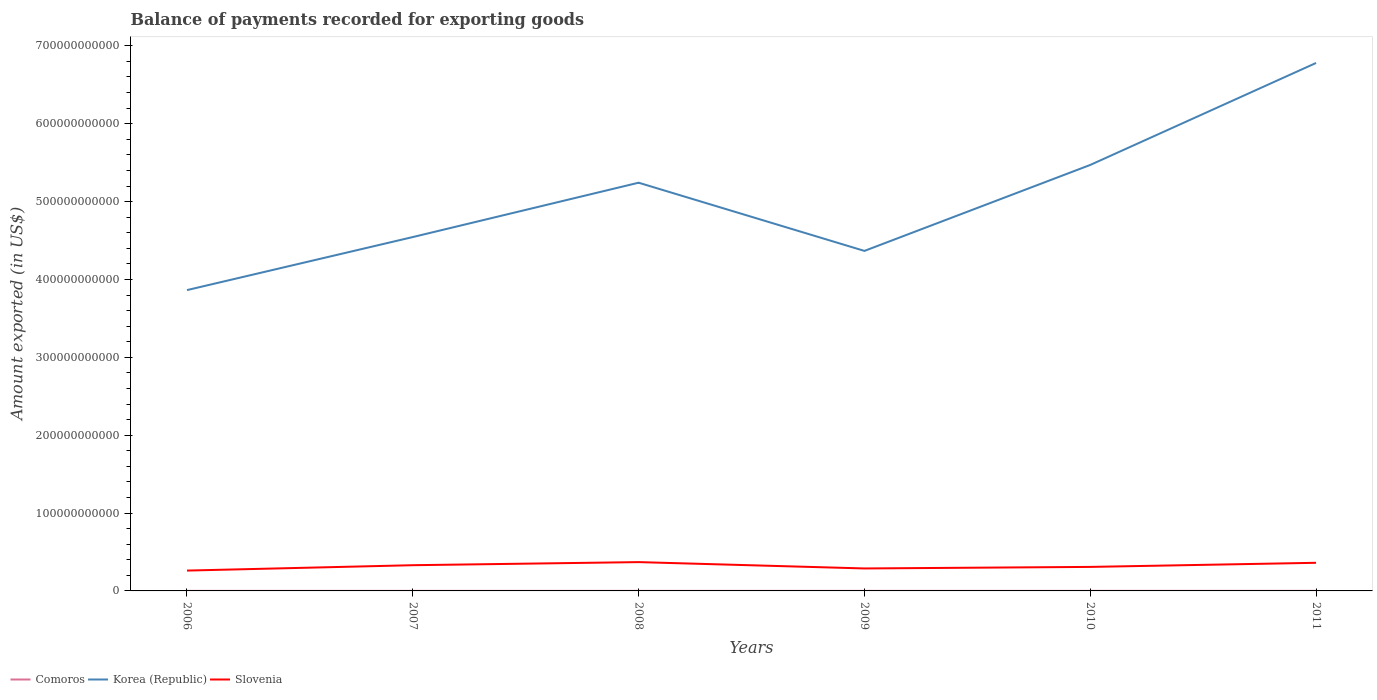Across all years, what is the maximum amount exported in Comoros?
Your response must be concise. 6.01e+07. What is the total amount exported in Korea (Republic) in the graph?
Your answer should be compact. 8.76e+1. What is the difference between the highest and the second highest amount exported in Comoros?
Ensure brevity in your answer.  3.95e+07. What is the difference between the highest and the lowest amount exported in Korea (Republic)?
Provide a succinct answer. 3. How many years are there in the graph?
Offer a terse response. 6. What is the difference between two consecutive major ticks on the Y-axis?
Your answer should be compact. 1.00e+11. Are the values on the major ticks of Y-axis written in scientific E-notation?
Offer a very short reply. No. Does the graph contain grids?
Offer a terse response. No. Where does the legend appear in the graph?
Keep it short and to the point. Bottom left. What is the title of the graph?
Your answer should be very brief. Balance of payments recorded for exporting goods. Does "Latin America(all income levels)" appear as one of the legend labels in the graph?
Your answer should be very brief. No. What is the label or title of the X-axis?
Your answer should be compact. Years. What is the label or title of the Y-axis?
Keep it short and to the point. Amount exported (in US$). What is the Amount exported (in US$) in Comoros in 2006?
Keep it short and to the point. 6.01e+07. What is the Amount exported (in US$) of Korea (Republic) in 2006?
Ensure brevity in your answer.  3.86e+11. What is the Amount exported (in US$) of Slovenia in 2006?
Provide a short and direct response. 2.61e+1. What is the Amount exported (in US$) of Comoros in 2007?
Your answer should be compact. 7.15e+07. What is the Amount exported (in US$) of Korea (Republic) in 2007?
Provide a succinct answer. 4.54e+11. What is the Amount exported (in US$) of Slovenia in 2007?
Your answer should be compact. 3.30e+1. What is the Amount exported (in US$) in Comoros in 2008?
Your response must be concise. 7.41e+07. What is the Amount exported (in US$) in Korea (Republic) in 2008?
Ensure brevity in your answer.  5.24e+11. What is the Amount exported (in US$) of Slovenia in 2008?
Provide a succinct answer. 3.70e+1. What is the Amount exported (in US$) in Comoros in 2009?
Ensure brevity in your answer.  7.77e+07. What is the Amount exported (in US$) of Korea (Republic) in 2009?
Provide a succinct answer. 4.37e+11. What is the Amount exported (in US$) in Slovenia in 2009?
Your response must be concise. 2.88e+1. What is the Amount exported (in US$) of Comoros in 2010?
Make the answer very short. 8.74e+07. What is the Amount exported (in US$) of Korea (Republic) in 2010?
Keep it short and to the point. 5.47e+11. What is the Amount exported (in US$) of Slovenia in 2010?
Give a very brief answer. 3.08e+1. What is the Amount exported (in US$) in Comoros in 2011?
Your answer should be very brief. 9.96e+07. What is the Amount exported (in US$) of Korea (Republic) in 2011?
Give a very brief answer. 6.78e+11. What is the Amount exported (in US$) of Slovenia in 2011?
Provide a short and direct response. 3.61e+1. Across all years, what is the maximum Amount exported (in US$) of Comoros?
Give a very brief answer. 9.96e+07. Across all years, what is the maximum Amount exported (in US$) of Korea (Republic)?
Offer a terse response. 6.78e+11. Across all years, what is the maximum Amount exported (in US$) of Slovenia?
Your response must be concise. 3.70e+1. Across all years, what is the minimum Amount exported (in US$) of Comoros?
Your answer should be very brief. 6.01e+07. Across all years, what is the minimum Amount exported (in US$) in Korea (Republic)?
Make the answer very short. 3.86e+11. Across all years, what is the minimum Amount exported (in US$) in Slovenia?
Give a very brief answer. 2.61e+1. What is the total Amount exported (in US$) in Comoros in the graph?
Offer a terse response. 4.71e+08. What is the total Amount exported (in US$) of Korea (Republic) in the graph?
Offer a terse response. 3.03e+12. What is the total Amount exported (in US$) in Slovenia in the graph?
Make the answer very short. 1.92e+11. What is the difference between the Amount exported (in US$) in Comoros in 2006 and that in 2007?
Your answer should be compact. -1.14e+07. What is the difference between the Amount exported (in US$) of Korea (Republic) in 2006 and that in 2007?
Make the answer very short. -6.81e+1. What is the difference between the Amount exported (in US$) in Slovenia in 2006 and that in 2007?
Make the answer very short. -6.91e+09. What is the difference between the Amount exported (in US$) of Comoros in 2006 and that in 2008?
Give a very brief answer. -1.40e+07. What is the difference between the Amount exported (in US$) in Korea (Republic) in 2006 and that in 2008?
Ensure brevity in your answer.  -1.38e+11. What is the difference between the Amount exported (in US$) in Slovenia in 2006 and that in 2008?
Your answer should be very brief. -1.09e+1. What is the difference between the Amount exported (in US$) in Comoros in 2006 and that in 2009?
Ensure brevity in your answer.  -1.76e+07. What is the difference between the Amount exported (in US$) of Korea (Republic) in 2006 and that in 2009?
Ensure brevity in your answer.  -5.03e+1. What is the difference between the Amount exported (in US$) in Slovenia in 2006 and that in 2009?
Your answer should be very brief. -2.73e+09. What is the difference between the Amount exported (in US$) of Comoros in 2006 and that in 2010?
Your response must be concise. -2.73e+07. What is the difference between the Amount exported (in US$) in Korea (Republic) in 2006 and that in 2010?
Ensure brevity in your answer.  -1.61e+11. What is the difference between the Amount exported (in US$) of Slovenia in 2006 and that in 2010?
Offer a very short reply. -4.72e+09. What is the difference between the Amount exported (in US$) of Comoros in 2006 and that in 2011?
Ensure brevity in your answer.  -3.95e+07. What is the difference between the Amount exported (in US$) of Korea (Republic) in 2006 and that in 2011?
Make the answer very short. -2.92e+11. What is the difference between the Amount exported (in US$) of Slovenia in 2006 and that in 2011?
Keep it short and to the point. -9.99e+09. What is the difference between the Amount exported (in US$) of Comoros in 2007 and that in 2008?
Your response must be concise. -2.64e+06. What is the difference between the Amount exported (in US$) of Korea (Republic) in 2007 and that in 2008?
Your response must be concise. -6.98e+1. What is the difference between the Amount exported (in US$) in Slovenia in 2007 and that in 2008?
Give a very brief answer. -3.97e+09. What is the difference between the Amount exported (in US$) in Comoros in 2007 and that in 2009?
Give a very brief answer. -6.22e+06. What is the difference between the Amount exported (in US$) of Korea (Republic) in 2007 and that in 2009?
Give a very brief answer. 1.78e+1. What is the difference between the Amount exported (in US$) in Slovenia in 2007 and that in 2009?
Provide a succinct answer. 4.18e+09. What is the difference between the Amount exported (in US$) of Comoros in 2007 and that in 2010?
Your answer should be compact. -1.59e+07. What is the difference between the Amount exported (in US$) in Korea (Republic) in 2007 and that in 2010?
Make the answer very short. -9.26e+1. What is the difference between the Amount exported (in US$) of Slovenia in 2007 and that in 2010?
Make the answer very short. 2.19e+09. What is the difference between the Amount exported (in US$) in Comoros in 2007 and that in 2011?
Offer a very short reply. -2.82e+07. What is the difference between the Amount exported (in US$) in Korea (Republic) in 2007 and that in 2011?
Your answer should be very brief. -2.24e+11. What is the difference between the Amount exported (in US$) of Slovenia in 2007 and that in 2011?
Offer a very short reply. -3.08e+09. What is the difference between the Amount exported (in US$) of Comoros in 2008 and that in 2009?
Offer a very short reply. -3.57e+06. What is the difference between the Amount exported (in US$) in Korea (Republic) in 2008 and that in 2009?
Offer a very short reply. 8.76e+1. What is the difference between the Amount exported (in US$) in Slovenia in 2008 and that in 2009?
Provide a short and direct response. 8.15e+09. What is the difference between the Amount exported (in US$) in Comoros in 2008 and that in 2010?
Keep it short and to the point. -1.33e+07. What is the difference between the Amount exported (in US$) of Korea (Republic) in 2008 and that in 2010?
Your answer should be very brief. -2.28e+1. What is the difference between the Amount exported (in US$) in Slovenia in 2008 and that in 2010?
Provide a short and direct response. 6.16e+09. What is the difference between the Amount exported (in US$) of Comoros in 2008 and that in 2011?
Keep it short and to the point. -2.55e+07. What is the difference between the Amount exported (in US$) of Korea (Republic) in 2008 and that in 2011?
Give a very brief answer. -1.54e+11. What is the difference between the Amount exported (in US$) of Slovenia in 2008 and that in 2011?
Make the answer very short. 8.89e+08. What is the difference between the Amount exported (in US$) of Comoros in 2009 and that in 2010?
Provide a succinct answer. -9.73e+06. What is the difference between the Amount exported (in US$) in Korea (Republic) in 2009 and that in 2010?
Ensure brevity in your answer.  -1.10e+11. What is the difference between the Amount exported (in US$) in Slovenia in 2009 and that in 2010?
Keep it short and to the point. -1.99e+09. What is the difference between the Amount exported (in US$) in Comoros in 2009 and that in 2011?
Your answer should be compact. -2.19e+07. What is the difference between the Amount exported (in US$) of Korea (Republic) in 2009 and that in 2011?
Your response must be concise. -2.41e+11. What is the difference between the Amount exported (in US$) in Slovenia in 2009 and that in 2011?
Provide a short and direct response. -7.26e+09. What is the difference between the Amount exported (in US$) in Comoros in 2010 and that in 2011?
Offer a terse response. -1.22e+07. What is the difference between the Amount exported (in US$) in Korea (Republic) in 2010 and that in 2011?
Provide a short and direct response. -1.31e+11. What is the difference between the Amount exported (in US$) in Slovenia in 2010 and that in 2011?
Give a very brief answer. -5.27e+09. What is the difference between the Amount exported (in US$) of Comoros in 2006 and the Amount exported (in US$) of Korea (Republic) in 2007?
Offer a very short reply. -4.54e+11. What is the difference between the Amount exported (in US$) in Comoros in 2006 and the Amount exported (in US$) in Slovenia in 2007?
Provide a short and direct response. -3.30e+1. What is the difference between the Amount exported (in US$) in Korea (Republic) in 2006 and the Amount exported (in US$) in Slovenia in 2007?
Your response must be concise. 3.53e+11. What is the difference between the Amount exported (in US$) in Comoros in 2006 and the Amount exported (in US$) in Korea (Republic) in 2008?
Your response must be concise. -5.24e+11. What is the difference between the Amount exported (in US$) of Comoros in 2006 and the Amount exported (in US$) of Slovenia in 2008?
Provide a succinct answer. -3.69e+1. What is the difference between the Amount exported (in US$) of Korea (Republic) in 2006 and the Amount exported (in US$) of Slovenia in 2008?
Offer a terse response. 3.49e+11. What is the difference between the Amount exported (in US$) of Comoros in 2006 and the Amount exported (in US$) of Korea (Republic) in 2009?
Your answer should be very brief. -4.37e+11. What is the difference between the Amount exported (in US$) of Comoros in 2006 and the Amount exported (in US$) of Slovenia in 2009?
Make the answer very short. -2.88e+1. What is the difference between the Amount exported (in US$) of Korea (Republic) in 2006 and the Amount exported (in US$) of Slovenia in 2009?
Make the answer very short. 3.57e+11. What is the difference between the Amount exported (in US$) in Comoros in 2006 and the Amount exported (in US$) in Korea (Republic) in 2010?
Your answer should be very brief. -5.47e+11. What is the difference between the Amount exported (in US$) of Comoros in 2006 and the Amount exported (in US$) of Slovenia in 2010?
Offer a terse response. -3.08e+1. What is the difference between the Amount exported (in US$) of Korea (Republic) in 2006 and the Amount exported (in US$) of Slovenia in 2010?
Offer a very short reply. 3.55e+11. What is the difference between the Amount exported (in US$) in Comoros in 2006 and the Amount exported (in US$) in Korea (Republic) in 2011?
Keep it short and to the point. -6.78e+11. What is the difference between the Amount exported (in US$) in Comoros in 2006 and the Amount exported (in US$) in Slovenia in 2011?
Provide a short and direct response. -3.61e+1. What is the difference between the Amount exported (in US$) in Korea (Republic) in 2006 and the Amount exported (in US$) in Slovenia in 2011?
Give a very brief answer. 3.50e+11. What is the difference between the Amount exported (in US$) in Comoros in 2007 and the Amount exported (in US$) in Korea (Republic) in 2008?
Provide a short and direct response. -5.24e+11. What is the difference between the Amount exported (in US$) in Comoros in 2007 and the Amount exported (in US$) in Slovenia in 2008?
Keep it short and to the point. -3.69e+1. What is the difference between the Amount exported (in US$) in Korea (Republic) in 2007 and the Amount exported (in US$) in Slovenia in 2008?
Keep it short and to the point. 4.17e+11. What is the difference between the Amount exported (in US$) in Comoros in 2007 and the Amount exported (in US$) in Korea (Republic) in 2009?
Your answer should be compact. -4.37e+11. What is the difference between the Amount exported (in US$) of Comoros in 2007 and the Amount exported (in US$) of Slovenia in 2009?
Keep it short and to the point. -2.88e+1. What is the difference between the Amount exported (in US$) of Korea (Republic) in 2007 and the Amount exported (in US$) of Slovenia in 2009?
Ensure brevity in your answer.  4.26e+11. What is the difference between the Amount exported (in US$) in Comoros in 2007 and the Amount exported (in US$) in Korea (Republic) in 2010?
Make the answer very short. -5.47e+11. What is the difference between the Amount exported (in US$) in Comoros in 2007 and the Amount exported (in US$) in Slovenia in 2010?
Ensure brevity in your answer.  -3.08e+1. What is the difference between the Amount exported (in US$) of Korea (Republic) in 2007 and the Amount exported (in US$) of Slovenia in 2010?
Your response must be concise. 4.24e+11. What is the difference between the Amount exported (in US$) of Comoros in 2007 and the Amount exported (in US$) of Korea (Republic) in 2011?
Offer a very short reply. -6.78e+11. What is the difference between the Amount exported (in US$) in Comoros in 2007 and the Amount exported (in US$) in Slovenia in 2011?
Make the answer very short. -3.60e+1. What is the difference between the Amount exported (in US$) in Korea (Republic) in 2007 and the Amount exported (in US$) in Slovenia in 2011?
Your answer should be very brief. 4.18e+11. What is the difference between the Amount exported (in US$) in Comoros in 2008 and the Amount exported (in US$) in Korea (Republic) in 2009?
Provide a short and direct response. -4.37e+11. What is the difference between the Amount exported (in US$) of Comoros in 2008 and the Amount exported (in US$) of Slovenia in 2009?
Offer a terse response. -2.88e+1. What is the difference between the Amount exported (in US$) in Korea (Republic) in 2008 and the Amount exported (in US$) in Slovenia in 2009?
Ensure brevity in your answer.  4.95e+11. What is the difference between the Amount exported (in US$) in Comoros in 2008 and the Amount exported (in US$) in Korea (Republic) in 2010?
Make the answer very short. -5.47e+11. What is the difference between the Amount exported (in US$) in Comoros in 2008 and the Amount exported (in US$) in Slovenia in 2010?
Ensure brevity in your answer.  -3.08e+1. What is the difference between the Amount exported (in US$) in Korea (Republic) in 2008 and the Amount exported (in US$) in Slovenia in 2010?
Offer a terse response. 4.93e+11. What is the difference between the Amount exported (in US$) in Comoros in 2008 and the Amount exported (in US$) in Korea (Republic) in 2011?
Offer a very short reply. -6.78e+11. What is the difference between the Amount exported (in US$) in Comoros in 2008 and the Amount exported (in US$) in Slovenia in 2011?
Offer a terse response. -3.60e+1. What is the difference between the Amount exported (in US$) in Korea (Republic) in 2008 and the Amount exported (in US$) in Slovenia in 2011?
Give a very brief answer. 4.88e+11. What is the difference between the Amount exported (in US$) in Comoros in 2009 and the Amount exported (in US$) in Korea (Republic) in 2010?
Provide a short and direct response. -5.47e+11. What is the difference between the Amount exported (in US$) in Comoros in 2009 and the Amount exported (in US$) in Slovenia in 2010?
Keep it short and to the point. -3.08e+1. What is the difference between the Amount exported (in US$) of Korea (Republic) in 2009 and the Amount exported (in US$) of Slovenia in 2010?
Your answer should be very brief. 4.06e+11. What is the difference between the Amount exported (in US$) of Comoros in 2009 and the Amount exported (in US$) of Korea (Republic) in 2011?
Your answer should be very brief. -6.78e+11. What is the difference between the Amount exported (in US$) in Comoros in 2009 and the Amount exported (in US$) in Slovenia in 2011?
Make the answer very short. -3.60e+1. What is the difference between the Amount exported (in US$) in Korea (Republic) in 2009 and the Amount exported (in US$) in Slovenia in 2011?
Offer a very short reply. 4.01e+11. What is the difference between the Amount exported (in US$) in Comoros in 2010 and the Amount exported (in US$) in Korea (Republic) in 2011?
Make the answer very short. -6.78e+11. What is the difference between the Amount exported (in US$) of Comoros in 2010 and the Amount exported (in US$) of Slovenia in 2011?
Ensure brevity in your answer.  -3.60e+1. What is the difference between the Amount exported (in US$) in Korea (Republic) in 2010 and the Amount exported (in US$) in Slovenia in 2011?
Offer a very short reply. 5.11e+11. What is the average Amount exported (in US$) of Comoros per year?
Give a very brief answer. 7.84e+07. What is the average Amount exported (in US$) of Korea (Republic) per year?
Your response must be concise. 5.04e+11. What is the average Amount exported (in US$) in Slovenia per year?
Make the answer very short. 3.20e+1. In the year 2006, what is the difference between the Amount exported (in US$) in Comoros and Amount exported (in US$) in Korea (Republic)?
Ensure brevity in your answer.  -3.86e+11. In the year 2006, what is the difference between the Amount exported (in US$) in Comoros and Amount exported (in US$) in Slovenia?
Your answer should be very brief. -2.61e+1. In the year 2006, what is the difference between the Amount exported (in US$) in Korea (Republic) and Amount exported (in US$) in Slovenia?
Keep it short and to the point. 3.60e+11. In the year 2007, what is the difference between the Amount exported (in US$) of Comoros and Amount exported (in US$) of Korea (Republic)?
Your response must be concise. -4.54e+11. In the year 2007, what is the difference between the Amount exported (in US$) of Comoros and Amount exported (in US$) of Slovenia?
Ensure brevity in your answer.  -3.30e+1. In the year 2007, what is the difference between the Amount exported (in US$) of Korea (Republic) and Amount exported (in US$) of Slovenia?
Make the answer very short. 4.21e+11. In the year 2008, what is the difference between the Amount exported (in US$) of Comoros and Amount exported (in US$) of Korea (Republic)?
Your answer should be very brief. -5.24e+11. In the year 2008, what is the difference between the Amount exported (in US$) of Comoros and Amount exported (in US$) of Slovenia?
Your answer should be compact. -3.69e+1. In the year 2008, what is the difference between the Amount exported (in US$) in Korea (Republic) and Amount exported (in US$) in Slovenia?
Ensure brevity in your answer.  4.87e+11. In the year 2009, what is the difference between the Amount exported (in US$) in Comoros and Amount exported (in US$) in Korea (Republic)?
Ensure brevity in your answer.  -4.37e+11. In the year 2009, what is the difference between the Amount exported (in US$) of Comoros and Amount exported (in US$) of Slovenia?
Offer a very short reply. -2.88e+1. In the year 2009, what is the difference between the Amount exported (in US$) in Korea (Republic) and Amount exported (in US$) in Slovenia?
Your answer should be very brief. 4.08e+11. In the year 2010, what is the difference between the Amount exported (in US$) in Comoros and Amount exported (in US$) in Korea (Republic)?
Your answer should be very brief. -5.47e+11. In the year 2010, what is the difference between the Amount exported (in US$) of Comoros and Amount exported (in US$) of Slovenia?
Make the answer very short. -3.08e+1. In the year 2010, what is the difference between the Amount exported (in US$) in Korea (Republic) and Amount exported (in US$) in Slovenia?
Ensure brevity in your answer.  5.16e+11. In the year 2011, what is the difference between the Amount exported (in US$) of Comoros and Amount exported (in US$) of Korea (Republic)?
Your answer should be very brief. -6.78e+11. In the year 2011, what is the difference between the Amount exported (in US$) of Comoros and Amount exported (in US$) of Slovenia?
Offer a very short reply. -3.60e+1. In the year 2011, what is the difference between the Amount exported (in US$) in Korea (Republic) and Amount exported (in US$) in Slovenia?
Offer a terse response. 6.42e+11. What is the ratio of the Amount exported (in US$) of Comoros in 2006 to that in 2007?
Your response must be concise. 0.84. What is the ratio of the Amount exported (in US$) in Korea (Republic) in 2006 to that in 2007?
Provide a succinct answer. 0.85. What is the ratio of the Amount exported (in US$) of Slovenia in 2006 to that in 2007?
Keep it short and to the point. 0.79. What is the ratio of the Amount exported (in US$) of Comoros in 2006 to that in 2008?
Provide a succinct answer. 0.81. What is the ratio of the Amount exported (in US$) in Korea (Republic) in 2006 to that in 2008?
Your answer should be compact. 0.74. What is the ratio of the Amount exported (in US$) in Slovenia in 2006 to that in 2008?
Give a very brief answer. 0.71. What is the ratio of the Amount exported (in US$) of Comoros in 2006 to that in 2009?
Your answer should be compact. 0.77. What is the ratio of the Amount exported (in US$) of Korea (Republic) in 2006 to that in 2009?
Offer a terse response. 0.88. What is the ratio of the Amount exported (in US$) of Slovenia in 2006 to that in 2009?
Keep it short and to the point. 0.91. What is the ratio of the Amount exported (in US$) in Comoros in 2006 to that in 2010?
Ensure brevity in your answer.  0.69. What is the ratio of the Amount exported (in US$) of Korea (Republic) in 2006 to that in 2010?
Offer a terse response. 0.71. What is the ratio of the Amount exported (in US$) in Slovenia in 2006 to that in 2010?
Provide a short and direct response. 0.85. What is the ratio of the Amount exported (in US$) of Comoros in 2006 to that in 2011?
Your answer should be compact. 0.6. What is the ratio of the Amount exported (in US$) in Korea (Republic) in 2006 to that in 2011?
Provide a short and direct response. 0.57. What is the ratio of the Amount exported (in US$) in Slovenia in 2006 to that in 2011?
Your response must be concise. 0.72. What is the ratio of the Amount exported (in US$) of Korea (Republic) in 2007 to that in 2008?
Offer a very short reply. 0.87. What is the ratio of the Amount exported (in US$) in Slovenia in 2007 to that in 2008?
Your answer should be compact. 0.89. What is the ratio of the Amount exported (in US$) of Comoros in 2007 to that in 2009?
Make the answer very short. 0.92. What is the ratio of the Amount exported (in US$) of Korea (Republic) in 2007 to that in 2009?
Offer a very short reply. 1.04. What is the ratio of the Amount exported (in US$) of Slovenia in 2007 to that in 2009?
Provide a succinct answer. 1.14. What is the ratio of the Amount exported (in US$) in Comoros in 2007 to that in 2010?
Your response must be concise. 0.82. What is the ratio of the Amount exported (in US$) of Korea (Republic) in 2007 to that in 2010?
Offer a very short reply. 0.83. What is the ratio of the Amount exported (in US$) in Slovenia in 2007 to that in 2010?
Give a very brief answer. 1.07. What is the ratio of the Amount exported (in US$) of Comoros in 2007 to that in 2011?
Your answer should be compact. 0.72. What is the ratio of the Amount exported (in US$) of Korea (Republic) in 2007 to that in 2011?
Keep it short and to the point. 0.67. What is the ratio of the Amount exported (in US$) in Slovenia in 2007 to that in 2011?
Give a very brief answer. 0.91. What is the ratio of the Amount exported (in US$) of Comoros in 2008 to that in 2009?
Provide a short and direct response. 0.95. What is the ratio of the Amount exported (in US$) of Korea (Republic) in 2008 to that in 2009?
Give a very brief answer. 1.2. What is the ratio of the Amount exported (in US$) of Slovenia in 2008 to that in 2009?
Your answer should be very brief. 1.28. What is the ratio of the Amount exported (in US$) in Comoros in 2008 to that in 2010?
Offer a very short reply. 0.85. What is the ratio of the Amount exported (in US$) in Korea (Republic) in 2008 to that in 2010?
Offer a terse response. 0.96. What is the ratio of the Amount exported (in US$) in Slovenia in 2008 to that in 2010?
Make the answer very short. 1.2. What is the ratio of the Amount exported (in US$) of Comoros in 2008 to that in 2011?
Provide a succinct answer. 0.74. What is the ratio of the Amount exported (in US$) of Korea (Republic) in 2008 to that in 2011?
Your answer should be compact. 0.77. What is the ratio of the Amount exported (in US$) in Slovenia in 2008 to that in 2011?
Offer a terse response. 1.02. What is the ratio of the Amount exported (in US$) in Comoros in 2009 to that in 2010?
Make the answer very short. 0.89. What is the ratio of the Amount exported (in US$) in Korea (Republic) in 2009 to that in 2010?
Give a very brief answer. 0.8. What is the ratio of the Amount exported (in US$) in Slovenia in 2009 to that in 2010?
Ensure brevity in your answer.  0.94. What is the ratio of the Amount exported (in US$) in Comoros in 2009 to that in 2011?
Provide a succinct answer. 0.78. What is the ratio of the Amount exported (in US$) in Korea (Republic) in 2009 to that in 2011?
Offer a terse response. 0.64. What is the ratio of the Amount exported (in US$) of Slovenia in 2009 to that in 2011?
Ensure brevity in your answer.  0.8. What is the ratio of the Amount exported (in US$) in Comoros in 2010 to that in 2011?
Your response must be concise. 0.88. What is the ratio of the Amount exported (in US$) of Korea (Republic) in 2010 to that in 2011?
Offer a terse response. 0.81. What is the ratio of the Amount exported (in US$) in Slovenia in 2010 to that in 2011?
Ensure brevity in your answer.  0.85. What is the difference between the highest and the second highest Amount exported (in US$) of Comoros?
Keep it short and to the point. 1.22e+07. What is the difference between the highest and the second highest Amount exported (in US$) of Korea (Republic)?
Ensure brevity in your answer.  1.31e+11. What is the difference between the highest and the second highest Amount exported (in US$) of Slovenia?
Your answer should be very brief. 8.89e+08. What is the difference between the highest and the lowest Amount exported (in US$) of Comoros?
Your answer should be very brief. 3.95e+07. What is the difference between the highest and the lowest Amount exported (in US$) in Korea (Republic)?
Offer a terse response. 2.92e+11. What is the difference between the highest and the lowest Amount exported (in US$) in Slovenia?
Offer a very short reply. 1.09e+1. 